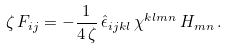<formula> <loc_0><loc_0><loc_500><loc_500>\zeta \, F _ { i j } = - \frac { 1 } { 4 \, \zeta } \, { \hat { \epsilon } } _ { i j k l } \, \chi ^ { k l m n } \, H _ { m n } \, .</formula> 